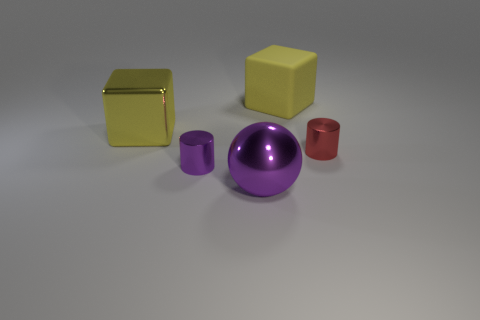Add 4 cyan matte cylinders. How many objects exist? 9 Subtract all cylinders. How many objects are left? 3 Add 5 large rubber cubes. How many large rubber cubes are left? 6 Add 5 red metallic things. How many red metallic things exist? 6 Subtract 0 green balls. How many objects are left? 5 Subtract all purple metal cylinders. Subtract all large shiny objects. How many objects are left? 2 